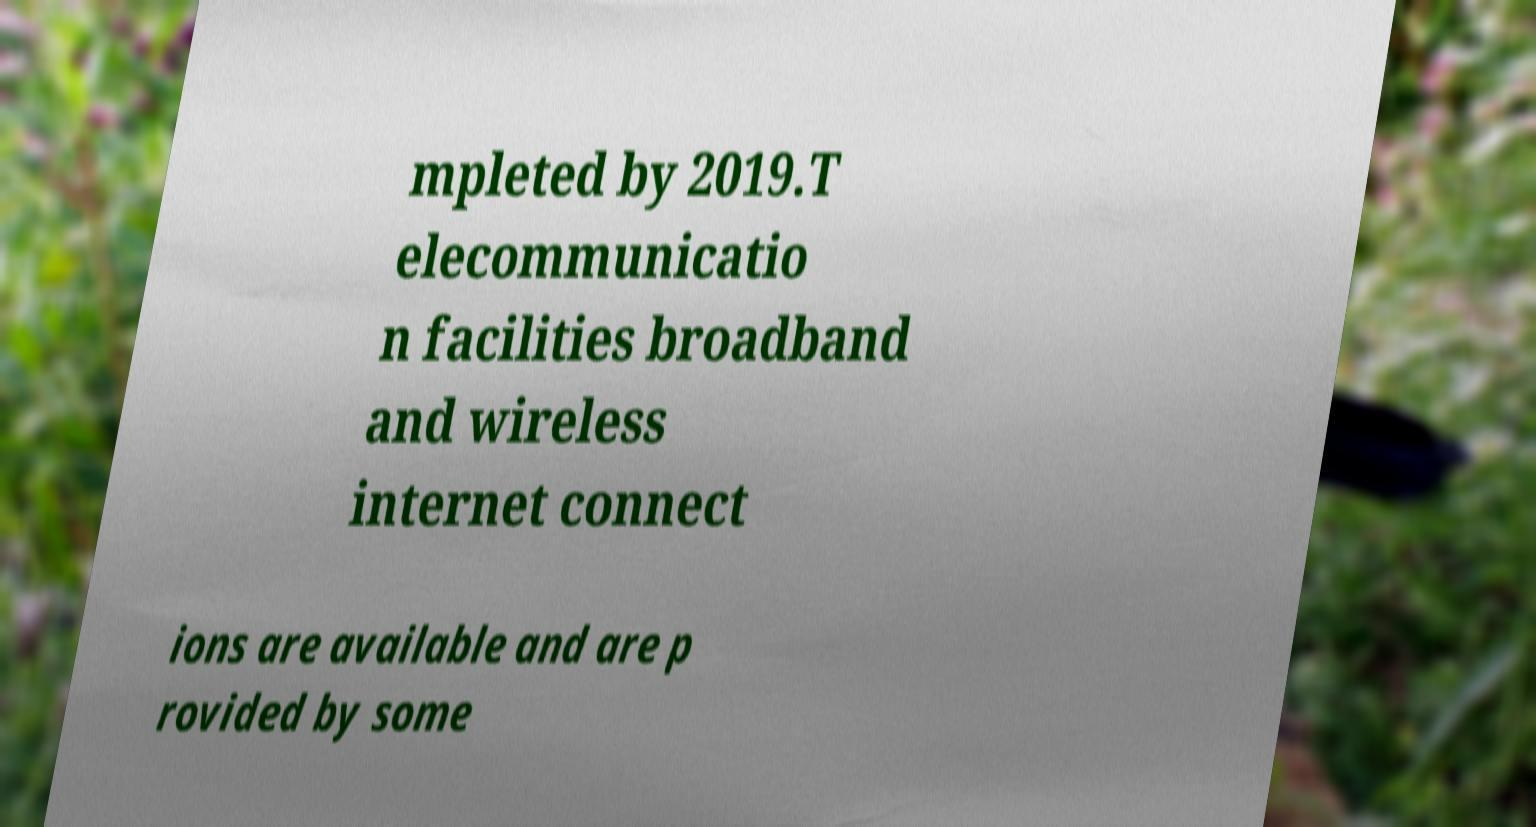Can you accurately transcribe the text from the provided image for me? mpleted by 2019.T elecommunicatio n facilities broadband and wireless internet connect ions are available and are p rovided by some 